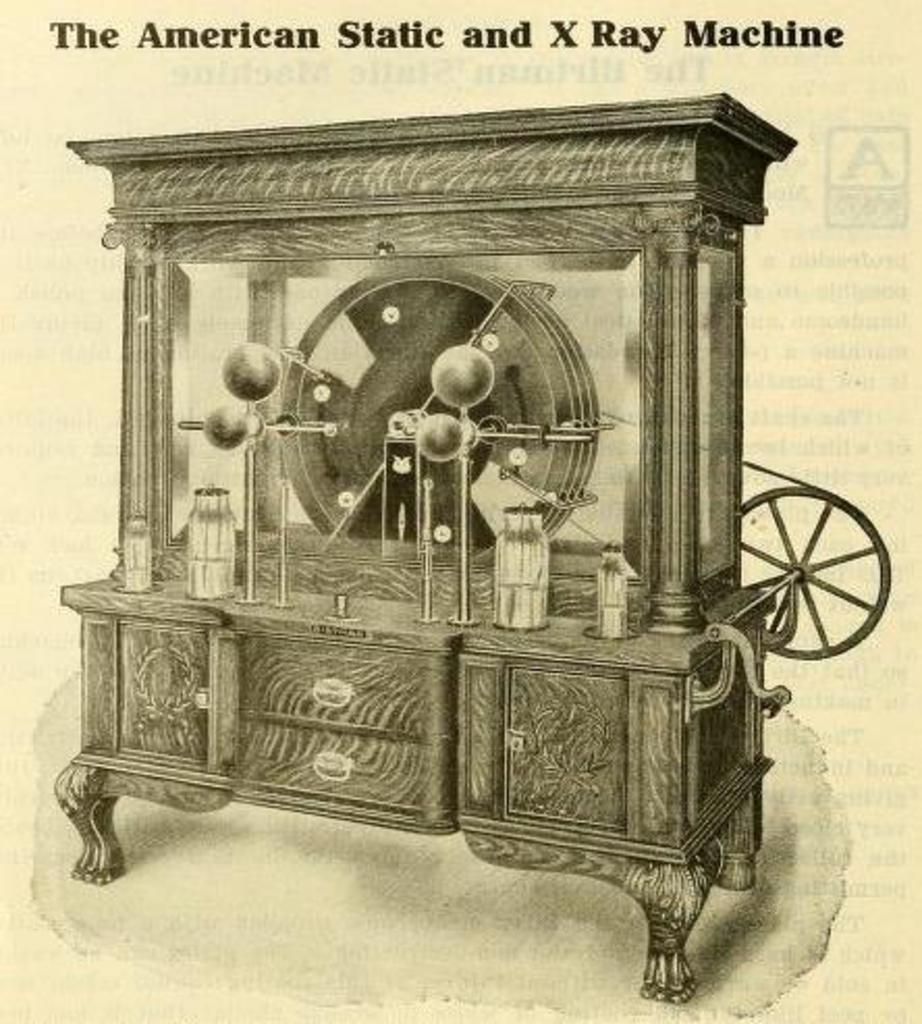What is the main subject of the poster in the image? The poster contains an image of an x-ray machine. How is the x-ray machine positioned in the image? The x-ray machine is depicted as being on a table. How many girls are shown using the x-ray machine in the image? There are no girls present in the image; it only features an image of an x-ray machine on a table. 